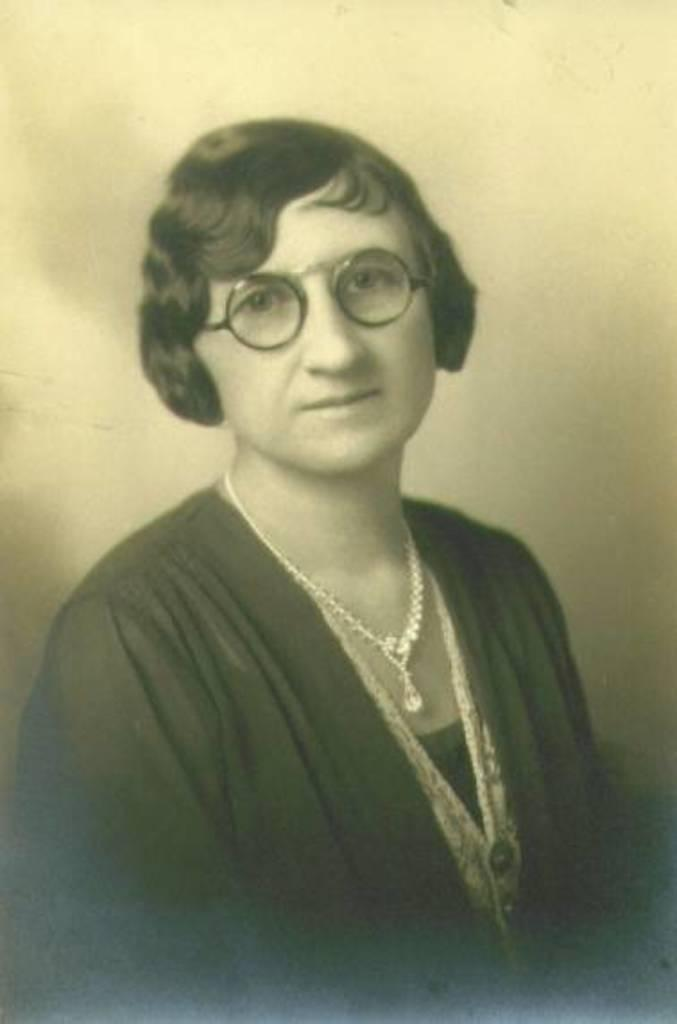Who is the main subject in the image? There is a woman in the image. What is the color scheme of the image? The image is in black and white. What accessory is the woman wearing in the image? The woman is wearing a necklace. What is the woman wearing on her face in the image? The woman is wearing spectacles. What can be seen behind the woman in the image? There is a wall behind the woman. What type of hen can be seen in the image? There is no hen present in the image. What is the texture of the woman's flesh in the image? The image is in black and white, so it is not possible to determine the texture of the woman's flesh. 